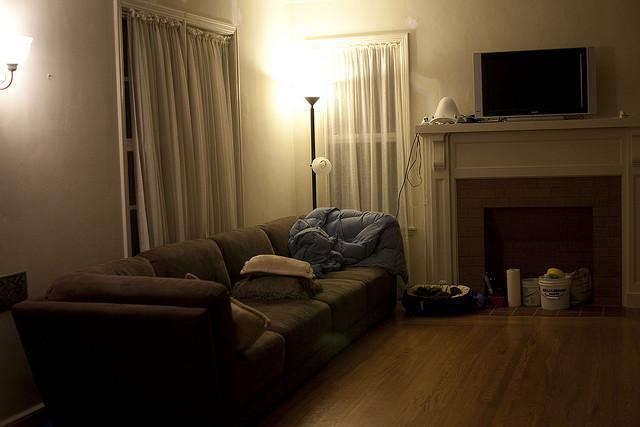How many lamps are in the room?
Give a very brief answer. 2. How many clocks are on the tower?
Give a very brief answer. 0. 